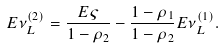<formula> <loc_0><loc_0><loc_500><loc_500>E \nu _ { L } ^ { ( 2 ) } = \frac { E \varsigma } { 1 - \rho _ { 2 } } - \frac { 1 - \rho _ { 1 } } { 1 - \rho _ { 2 } } E \nu _ { L } ^ { ( 1 ) } .</formula> 